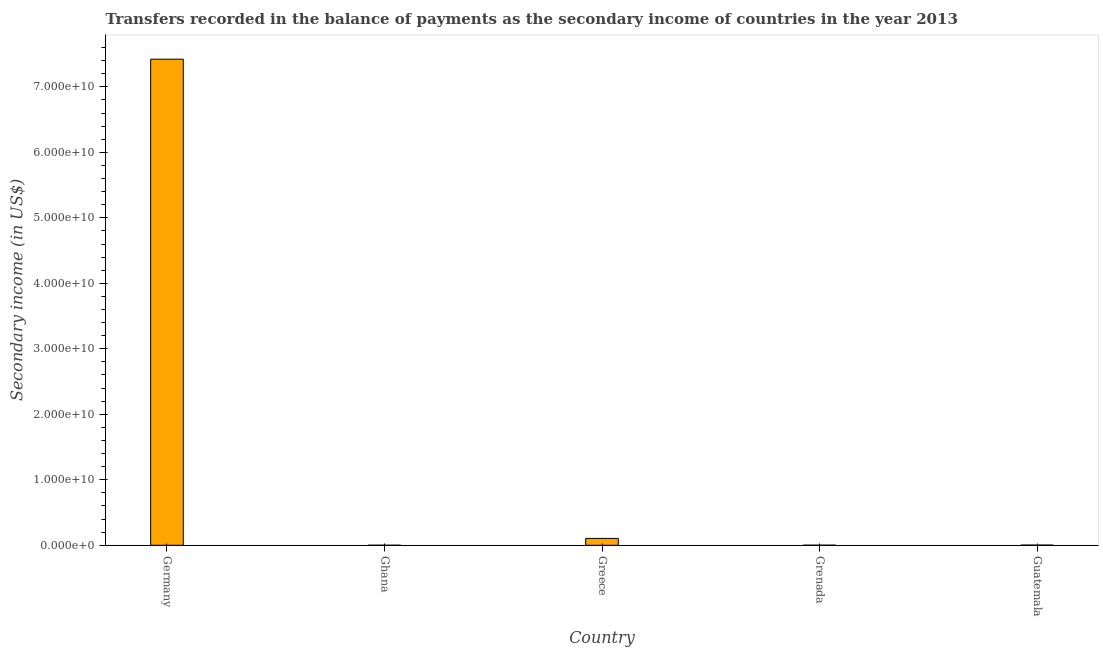Does the graph contain any zero values?
Your response must be concise. No. What is the title of the graph?
Your answer should be compact. Transfers recorded in the balance of payments as the secondary income of countries in the year 2013. What is the label or title of the X-axis?
Your answer should be compact. Country. What is the label or title of the Y-axis?
Offer a terse response. Secondary income (in US$). What is the amount of secondary income in Guatemala?
Offer a very short reply. 2.75e+07. Across all countries, what is the maximum amount of secondary income?
Give a very brief answer. 7.42e+1. Across all countries, what is the minimum amount of secondary income?
Provide a succinct answer. 4.80e+06. In which country was the amount of secondary income maximum?
Give a very brief answer. Germany. What is the sum of the amount of secondary income?
Offer a terse response. 7.53e+1. What is the difference between the amount of secondary income in Ghana and Guatemala?
Give a very brief answer. -2.27e+07. What is the average amount of secondary income per country?
Ensure brevity in your answer.  1.51e+1. What is the median amount of secondary income?
Offer a very short reply. 2.75e+07. In how many countries, is the amount of secondary income greater than 72000000000 US$?
Give a very brief answer. 1. What is the ratio of the amount of secondary income in Ghana to that in Grenada?
Make the answer very short. 0.43. What is the difference between the highest and the second highest amount of secondary income?
Provide a succinct answer. 7.32e+1. What is the difference between the highest and the lowest amount of secondary income?
Give a very brief answer. 7.42e+1. In how many countries, is the amount of secondary income greater than the average amount of secondary income taken over all countries?
Your answer should be very brief. 1. How many bars are there?
Keep it short and to the point. 5. Are all the bars in the graph horizontal?
Keep it short and to the point. No. How many countries are there in the graph?
Offer a very short reply. 5. Are the values on the major ticks of Y-axis written in scientific E-notation?
Provide a succinct answer. Yes. What is the Secondary income (in US$) of Germany?
Give a very brief answer. 7.42e+1. What is the Secondary income (in US$) of Ghana?
Ensure brevity in your answer.  4.80e+06. What is the Secondary income (in US$) in Greece?
Your answer should be very brief. 1.05e+09. What is the Secondary income (in US$) of Grenada?
Your answer should be compact. 1.12e+07. What is the Secondary income (in US$) in Guatemala?
Keep it short and to the point. 2.75e+07. What is the difference between the Secondary income (in US$) in Germany and Ghana?
Make the answer very short. 7.42e+1. What is the difference between the Secondary income (in US$) in Germany and Greece?
Provide a succinct answer. 7.32e+1. What is the difference between the Secondary income (in US$) in Germany and Grenada?
Ensure brevity in your answer.  7.42e+1. What is the difference between the Secondary income (in US$) in Germany and Guatemala?
Keep it short and to the point. 7.42e+1. What is the difference between the Secondary income (in US$) in Ghana and Greece?
Your response must be concise. -1.04e+09. What is the difference between the Secondary income (in US$) in Ghana and Grenada?
Offer a terse response. -6.43e+06. What is the difference between the Secondary income (in US$) in Ghana and Guatemala?
Your answer should be very brief. -2.27e+07. What is the difference between the Secondary income (in US$) in Greece and Grenada?
Offer a very short reply. 1.04e+09. What is the difference between the Secondary income (in US$) in Greece and Guatemala?
Offer a terse response. 1.02e+09. What is the difference between the Secondary income (in US$) in Grenada and Guatemala?
Your answer should be compact. -1.63e+07. What is the ratio of the Secondary income (in US$) in Germany to that in Ghana?
Ensure brevity in your answer.  1.55e+04. What is the ratio of the Secondary income (in US$) in Germany to that in Greece?
Provide a short and direct response. 70.88. What is the ratio of the Secondary income (in US$) in Germany to that in Grenada?
Keep it short and to the point. 6609.71. What is the ratio of the Secondary income (in US$) in Germany to that in Guatemala?
Your answer should be compact. 2697.56. What is the ratio of the Secondary income (in US$) in Ghana to that in Greece?
Offer a very short reply. 0.01. What is the ratio of the Secondary income (in US$) in Ghana to that in Grenada?
Provide a short and direct response. 0.43. What is the ratio of the Secondary income (in US$) in Ghana to that in Guatemala?
Your answer should be compact. 0.17. What is the ratio of the Secondary income (in US$) in Greece to that in Grenada?
Give a very brief answer. 93.26. What is the ratio of the Secondary income (in US$) in Greece to that in Guatemala?
Offer a terse response. 38.06. What is the ratio of the Secondary income (in US$) in Grenada to that in Guatemala?
Your response must be concise. 0.41. 